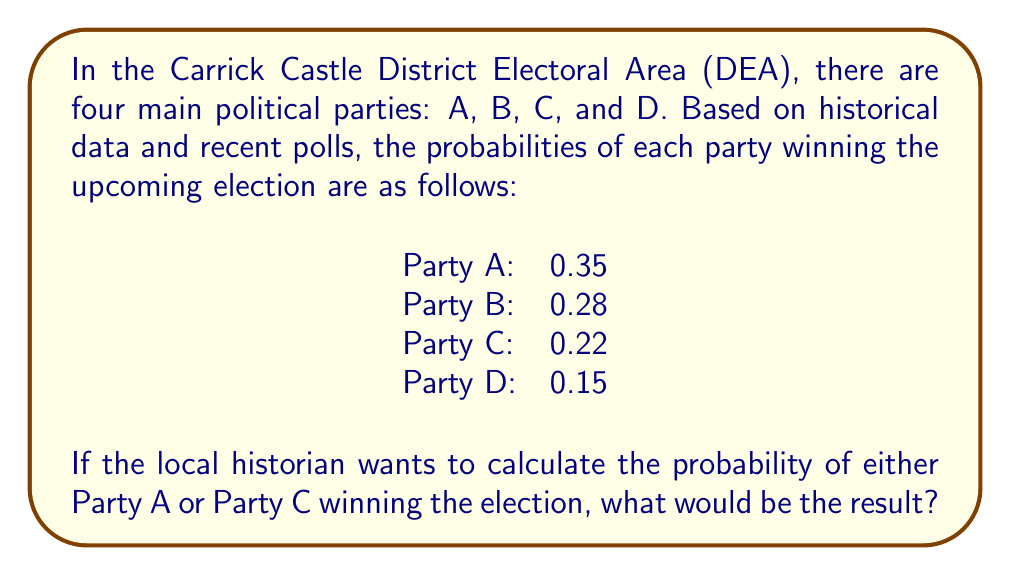Can you answer this question? To solve this problem, we need to follow these steps:

1. Identify the parties we're interested in: Party A and Party C.

2. Recall the addition rule of probability for mutually exclusive events:
   $P(A \text{ or } C) = P(A) + P(C)$

   This rule applies here because a party winning is mutually exclusive with other parties winning (only one party can win the election).

3. Substitute the given probabilities:
   $P(\text{Party A or Party C winning}) = P(\text{Party A winning}) + P(\text{Party C winning})$
   $= 0.35 + 0.22$

4. Calculate the sum:
   $= 0.57$

Therefore, the probability of either Party A or Party C winning the election is 0.57 or 57%.
Answer: 0.57 